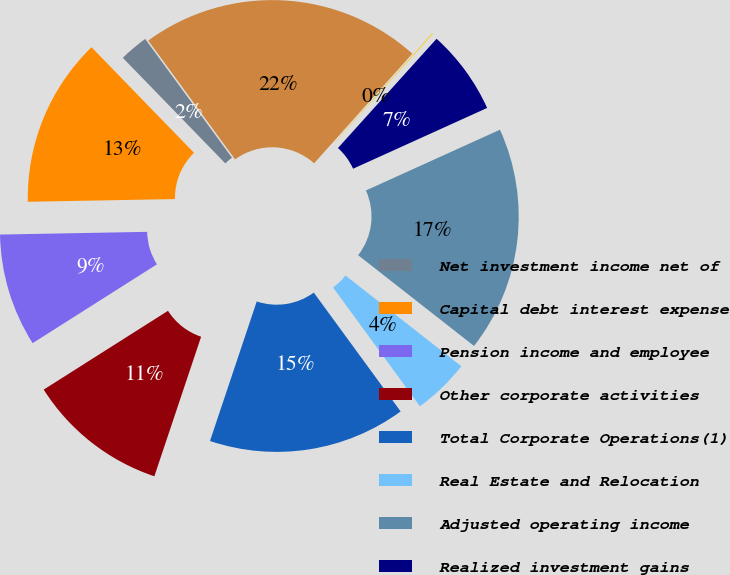Convert chart. <chart><loc_0><loc_0><loc_500><loc_500><pie_chart><fcel>Net investment income net of<fcel>Capital debt interest expense<fcel>Pension income and employee<fcel>Other corporate activities<fcel>Total Corporate Operations(1)<fcel>Real Estate and Relocation<fcel>Adjusted operating income<fcel>Realized investment gains<fcel>Related charges(3)<fcel>Divested businesses(4)<nl><fcel>2.22%<fcel>13.03%<fcel>8.7%<fcel>10.86%<fcel>15.19%<fcel>4.38%<fcel>17.35%<fcel>6.54%<fcel>0.06%<fcel>21.67%<nl></chart> 